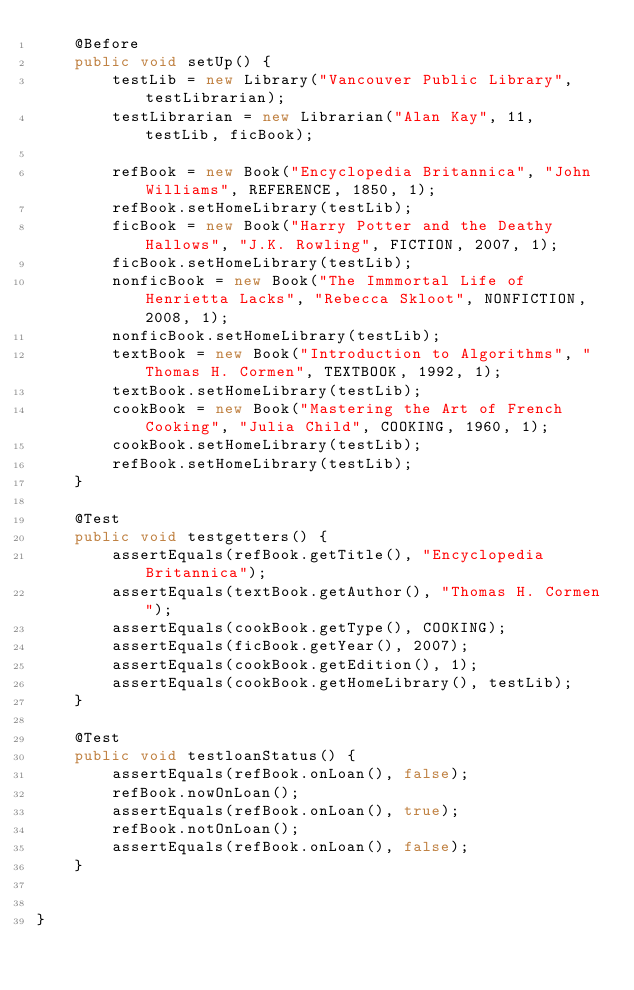Convert code to text. <code><loc_0><loc_0><loc_500><loc_500><_Java_>    @Before
    public void setUp() {
        testLib = new Library("Vancouver Public Library", testLibrarian);
        testLibrarian = new Librarian("Alan Kay", 11, testLib, ficBook);

        refBook = new Book("Encyclopedia Britannica", "John Williams", REFERENCE, 1850, 1);
        refBook.setHomeLibrary(testLib);
        ficBook = new Book("Harry Potter and the Deathy Hallows", "J.K. Rowling", FICTION, 2007, 1);
        ficBook.setHomeLibrary(testLib);
        nonficBook = new Book("The Immmortal Life of Henrietta Lacks", "Rebecca Skloot", NONFICTION, 2008, 1);
        nonficBook.setHomeLibrary(testLib);
        textBook = new Book("Introduction to Algorithms", "Thomas H. Cormen", TEXTBOOK, 1992, 1);
        textBook.setHomeLibrary(testLib);
        cookBook = new Book("Mastering the Art of French Cooking", "Julia Child", COOKING, 1960, 1);
        cookBook.setHomeLibrary(testLib);
        refBook.setHomeLibrary(testLib);
    }

    @Test
    public void testgetters() {
        assertEquals(refBook.getTitle(), "Encyclopedia Britannica");
        assertEquals(textBook.getAuthor(), "Thomas H. Cormen");
        assertEquals(cookBook.getType(), COOKING);
        assertEquals(ficBook.getYear(), 2007);
        assertEquals(cookBook.getEdition(), 1);
        assertEquals(cookBook.getHomeLibrary(), testLib);
    }

    @Test
    public void testloanStatus() {
        assertEquals(refBook.onLoan(), false);
        refBook.nowOnLoan();
        assertEquals(refBook.onLoan(), true);
        refBook.notOnLoan();
        assertEquals(refBook.onLoan(), false);
    }


}</code> 